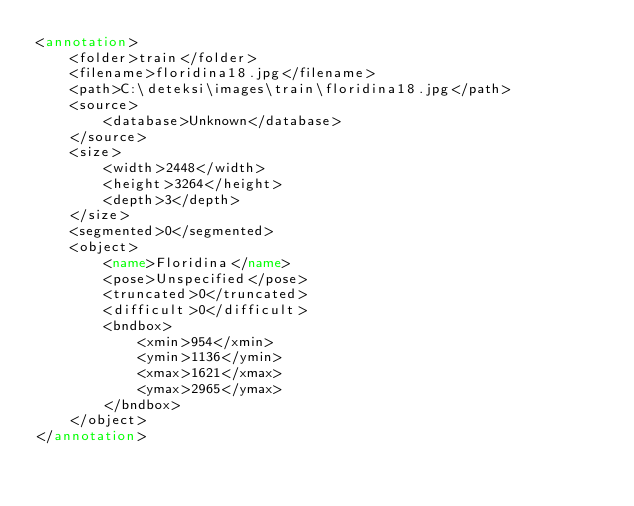Convert code to text. <code><loc_0><loc_0><loc_500><loc_500><_XML_><annotation>
	<folder>train</folder>
	<filename>floridina18.jpg</filename>
	<path>C:\deteksi\images\train\floridina18.jpg</path>
	<source>
		<database>Unknown</database>
	</source>
	<size>
		<width>2448</width>
		<height>3264</height>
		<depth>3</depth>
	</size>
	<segmented>0</segmented>
	<object>
		<name>Floridina</name>
		<pose>Unspecified</pose>
		<truncated>0</truncated>
		<difficult>0</difficult>
		<bndbox>
			<xmin>954</xmin>
			<ymin>1136</ymin>
			<xmax>1621</xmax>
			<ymax>2965</ymax>
		</bndbox>
	</object>
</annotation>
</code> 